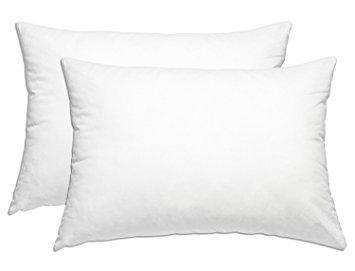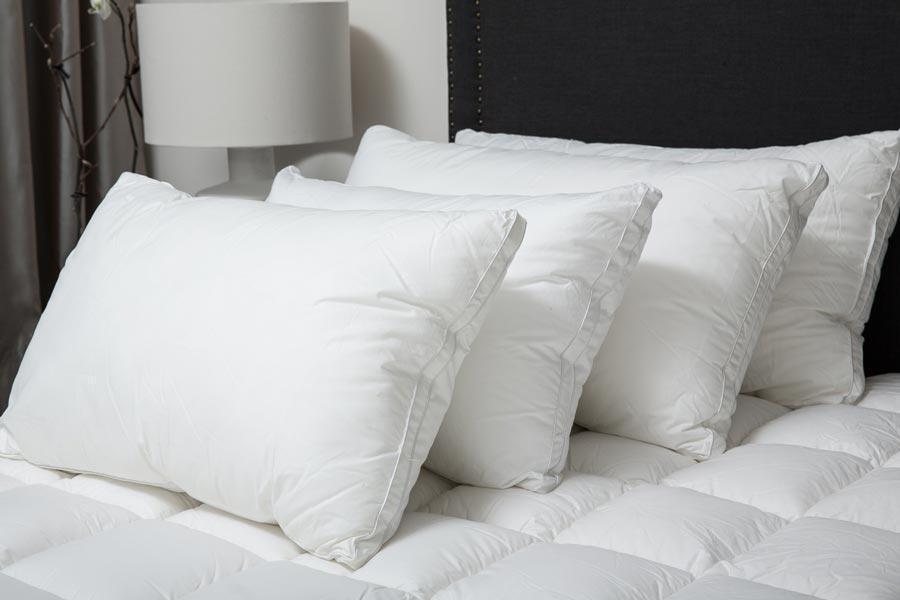The first image is the image on the left, the second image is the image on the right. Given the left and right images, does the statement "The pillows in the image on the left are propped against a padded headboard." hold true? Answer yes or no. No. The first image is the image on the left, the second image is the image on the right. Considering the images on both sides, is "An image shows a bed with tufted headboard and at least six pillows." valid? Answer yes or no. No. 